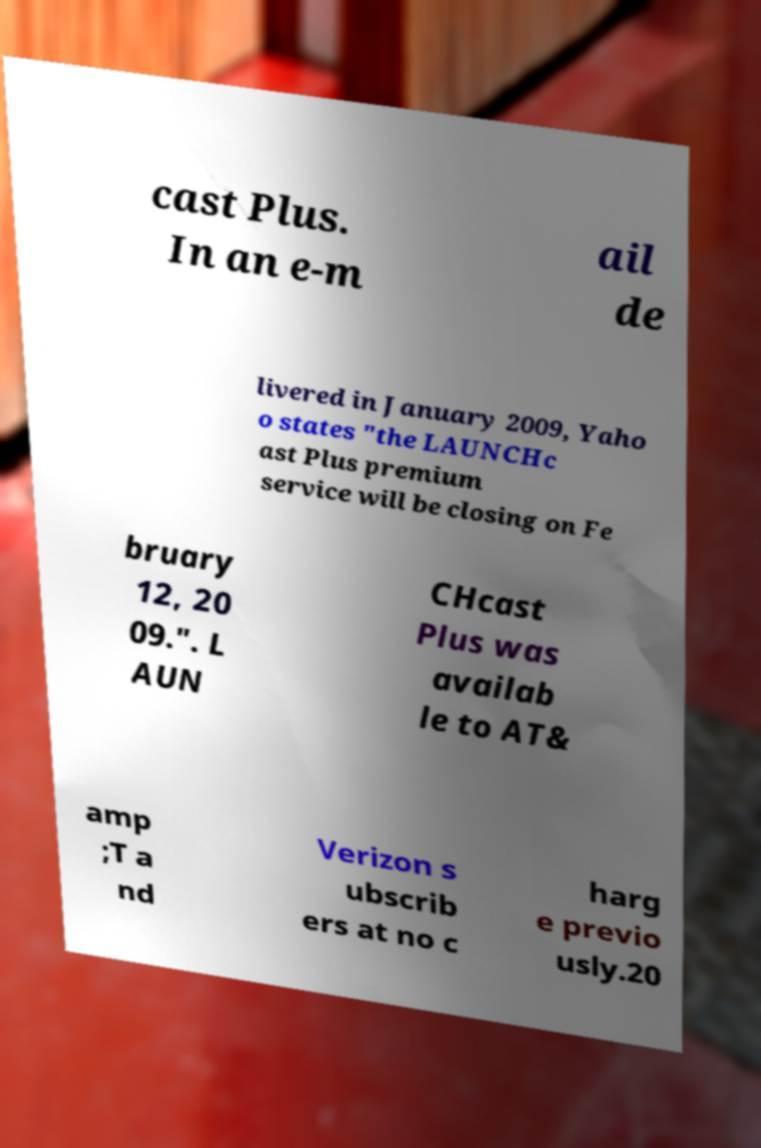Can you accurately transcribe the text from the provided image for me? cast Plus. In an e-m ail de livered in January 2009, Yaho o states "the LAUNCHc ast Plus premium service will be closing on Fe bruary 12, 20 09.". L AUN CHcast Plus was availab le to AT& amp ;T a nd Verizon s ubscrib ers at no c harg e previo usly.20 